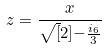<formula> <loc_0><loc_0><loc_500><loc_500>z = \frac { x } { \sqrt { [ } 2 ] { - \frac { i _ { 6 } } { 3 } } }</formula> 